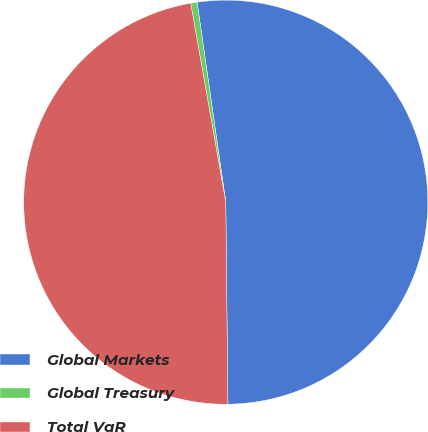Convert chart. <chart><loc_0><loc_0><loc_500><loc_500><pie_chart><fcel>Global Markets<fcel>Global Treasury<fcel>Total VaR<nl><fcel>52.1%<fcel>0.51%<fcel>47.39%<nl></chart> 